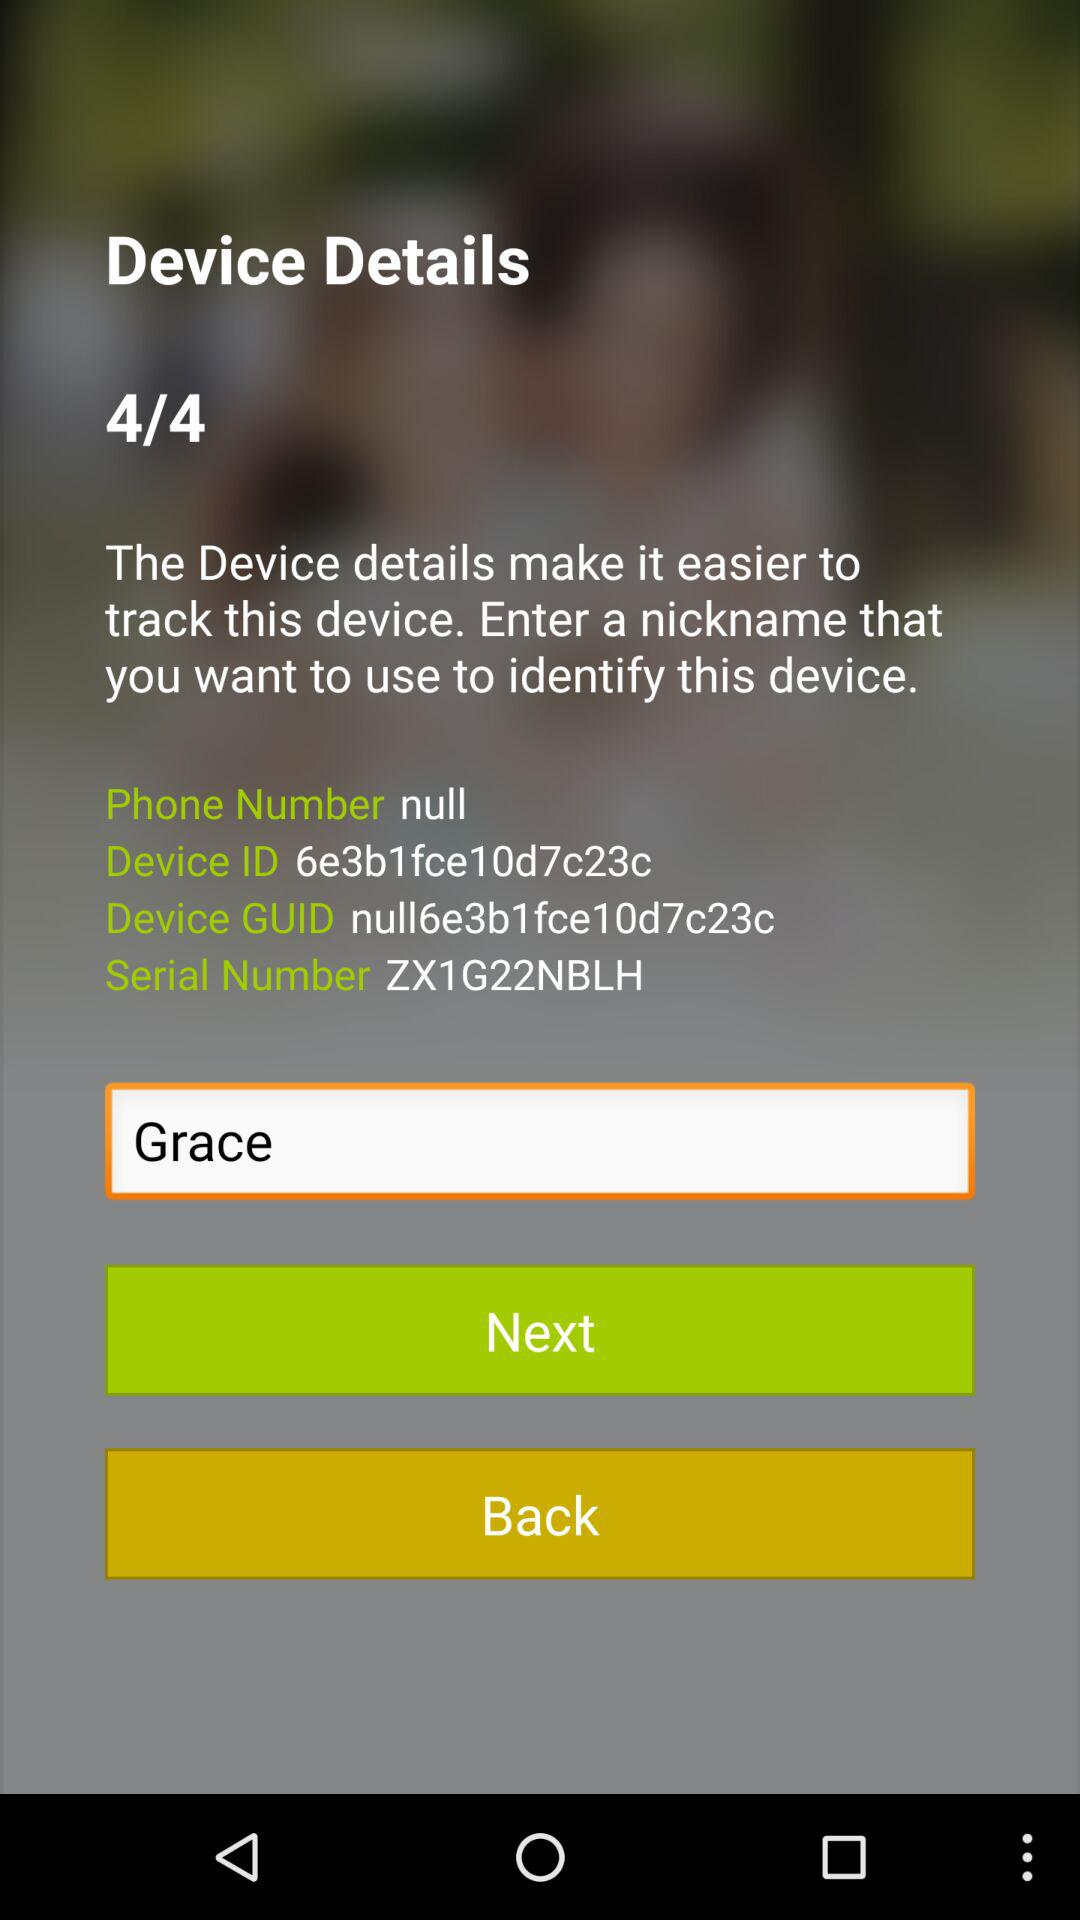What is the ID of the device? The ID of the device is 6e3b1fce10d7c23c. 